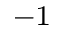Convert formula to latex. <formula><loc_0><loc_0><loc_500><loc_500>^ { - 1 }</formula> 